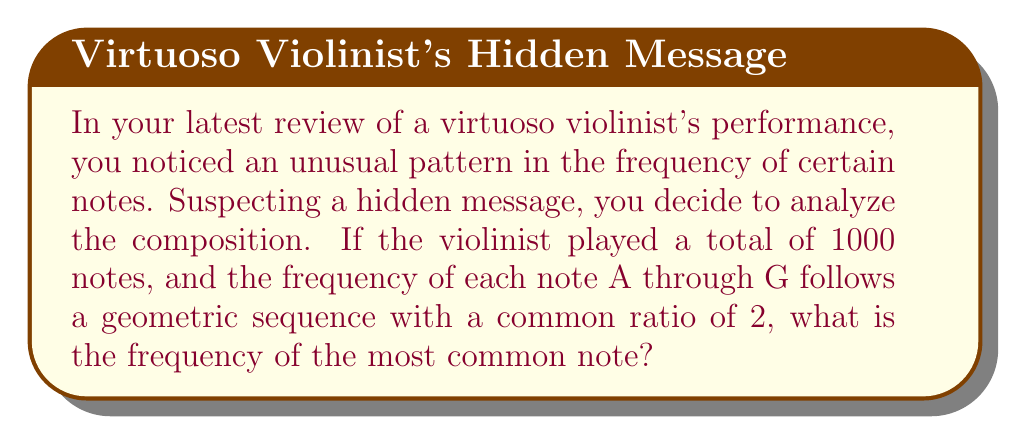Help me with this question. Let's approach this step-by-step:

1) In a geometric sequence, each term is a constant multiple of the previous term. Let's call this constant $r$, which we're told is 2.

2) Let's denote the frequency of the least common note as $a$. Then the frequencies of the seven notes (A through G) form the sequence:

   $a, ar, ar^2, ar^3, ar^4, ar^5, ar^6$

3) We know the sum of all frequencies must equal 1000:

   $a + ar + ar^2 + ar^3 + ar^4 + ar^5 + ar^6 = 1000$

4) This is a geometric series with 7 terms. The sum of a geometric series is given by the formula:

   $S_n = \frac{a(1-r^n)}{1-r}$ where $n$ is the number of terms

5) Substituting our values:

   $\frac{a(1-2^7)}{1-2} = 1000$

6) Simplify:

   $\frac{a(1-128)}{-1} = 1000$
   $127a = 1000$

7) Solve for $a$:

   $a = \frac{1000}{127} \approx 7.87$

8) The most common note will be the last term in our sequence: $ar^6$

9) Calculate:

   $ar^6 = 7.87 * 2^6 = 7.87 * 64 \approx 503.68$

10) Since we're dealing with whole notes, we round to the nearest integer: 504
Answer: 504 